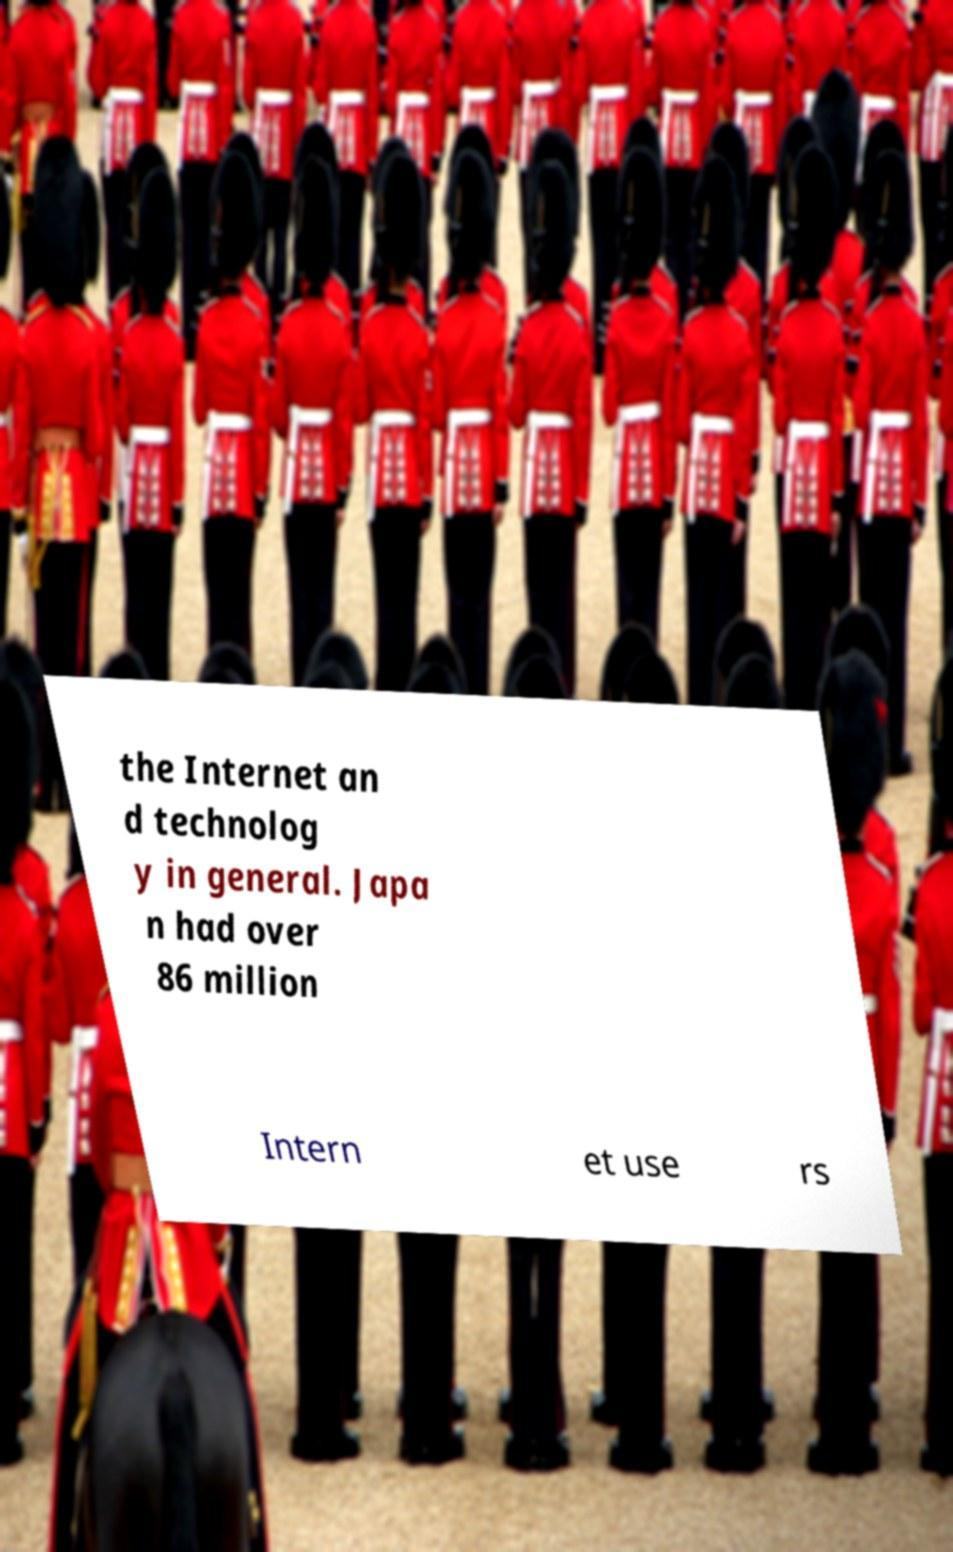Can you accurately transcribe the text from the provided image for me? the Internet an d technolog y in general. Japa n had over 86 million Intern et use rs 